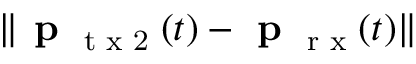Convert formula to latex. <formula><loc_0><loc_0><loc_500><loc_500>\| p _ { t x 2 } ( t ) - p _ { r x } ( t ) \|</formula> 